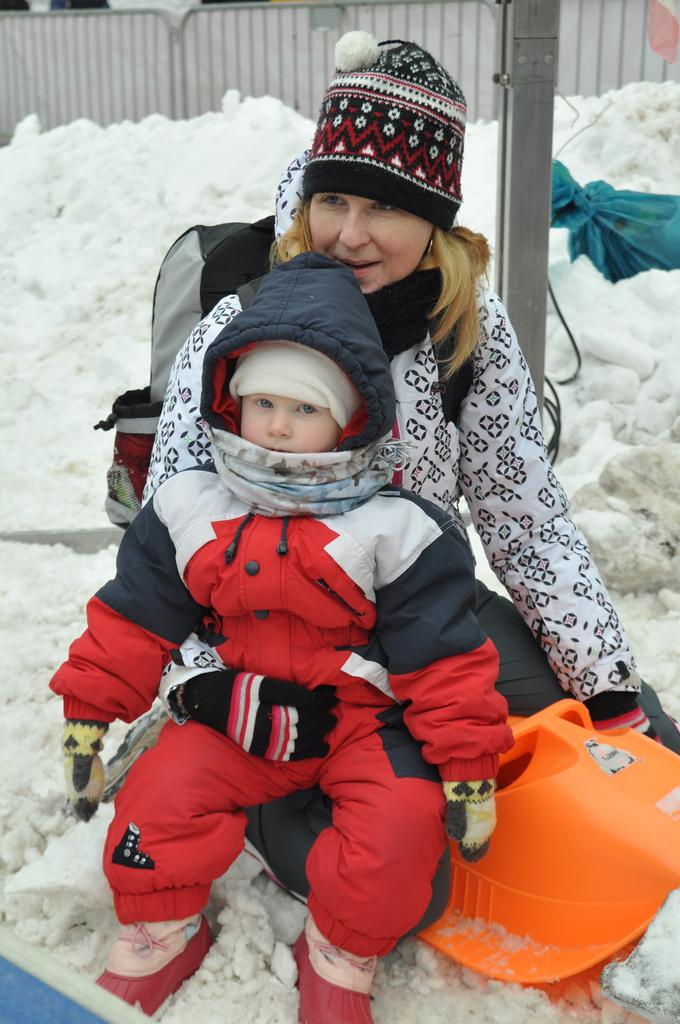What is the woman in the image doing? The woman is sitting in the middle of the image. What is the woman holding? The woman is holding a baby. What is the background of the image? There is snow visible behind the woman and baby. What is at the top of the image? There is fencing at the top of the image. What type of skirt is the woman wearing in the image? There is no information about the woman's skirt in the provided facts, so we cannot determine what type of skirt she is wearing. --- Facts: 1. There is a car in the image. 2. The car is parked on the street. 3. There are trees on both sides of the street. 4. The sky is visible in the image. 5. There is a traffic light in the background. Absurd Topics: parrot, dance, ocean Conversation: What is the main subject of the image? The main subject of the image is a car. Where is the car located in the image? The car is parked on the street. What can be seen on both sides of the street? There are trees on both sides of the street. What is visible in the background of the image? The sky is visible in the image. What is present in the background to regulate traffic? There is a traffic light in the background. Reasoning: Let's think step by step in order to produce the conversation. We start by identifying the main subject in the image, which is the car. Then, we expand the conversation to include the car's location, the presence of trees on both sides of the street, the visibility of the sky, and the traffic light in the background. Each question is designed to elicit a specific detail about the image that is known from the provided facts. Absurd Question/Answer: Can you see a parrot dancing near the ocean in the image? There is no mention of a parrot, dancing, or the ocean in the provided facts, so we cannot see any of these elements in the image. 